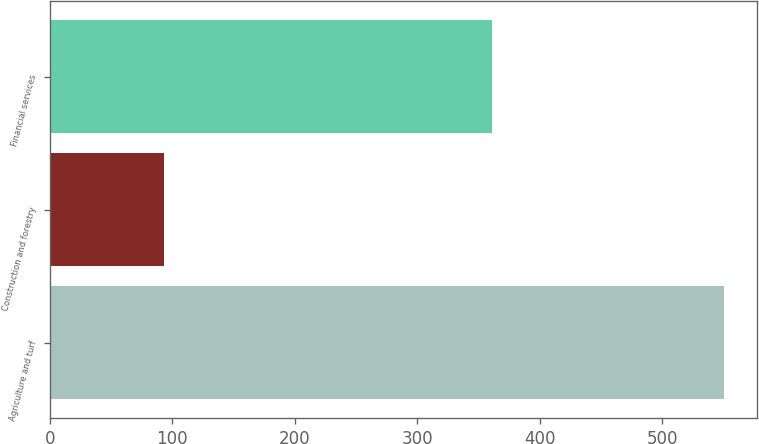Convert chart to OTSL. <chart><loc_0><loc_0><loc_500><loc_500><bar_chart><fcel>Agriculture and turf<fcel>Construction and forestry<fcel>Financial services<nl><fcel>550<fcel>93<fcel>361<nl></chart> 